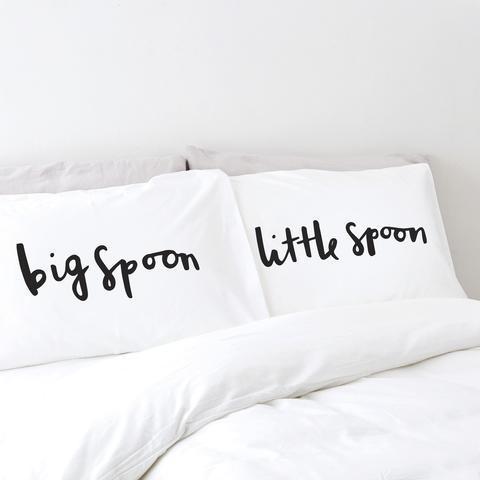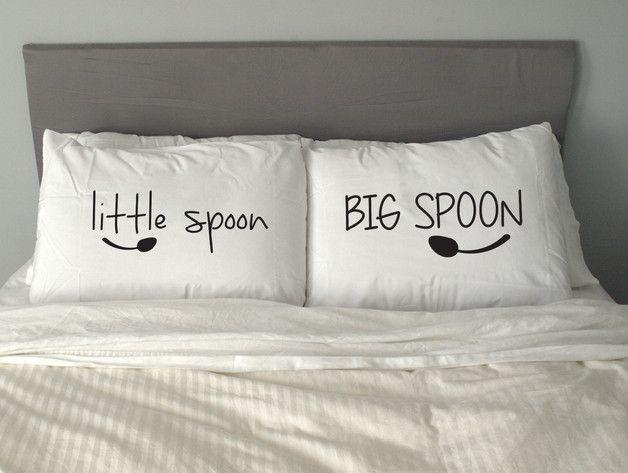The first image is the image on the left, the second image is the image on the right. Examine the images to the left and right. Is the description "There is no less than one sleeping woman visible" accurate? Answer yes or no. No. The first image is the image on the left, the second image is the image on the right. For the images shown, is this caption "there are humans sleeping" true? Answer yes or no. No. 